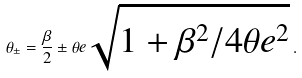<formula> <loc_0><loc_0><loc_500><loc_500>\theta _ { \pm } = \frac { \beta } { 2 } \pm \theta e \sqrt { 1 + { \beta ^ { 2 } } / { 4 \theta e ^ { 2 } } } \, .</formula> 